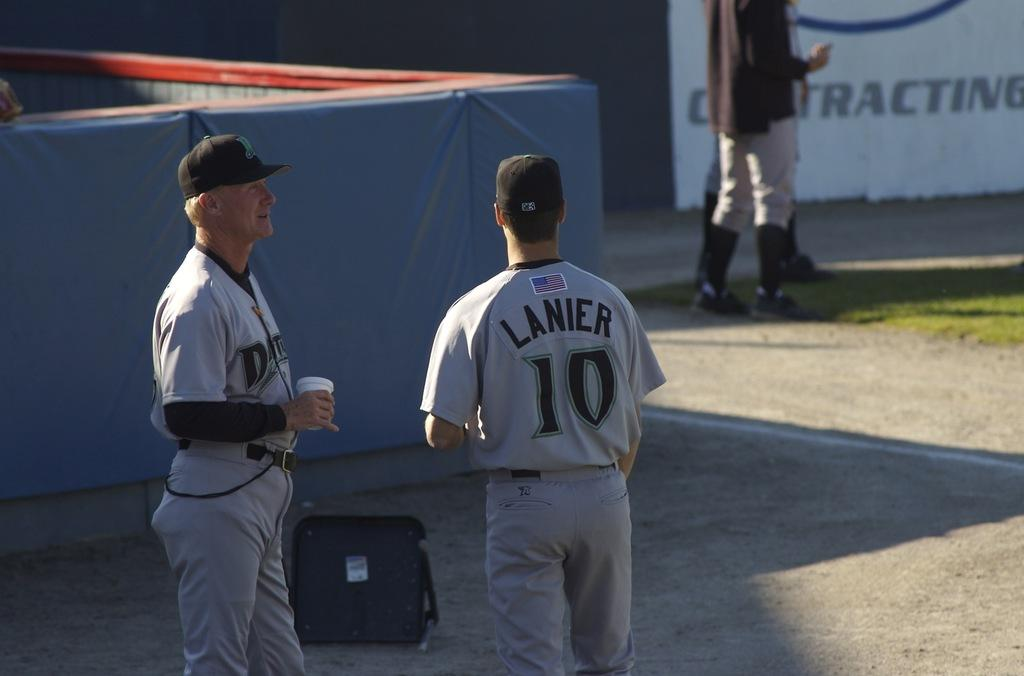Provide a one-sentence caption for the provided image. Two baseball players stand talking to each other, one of them in a uniform that says "Lanier 10.". 